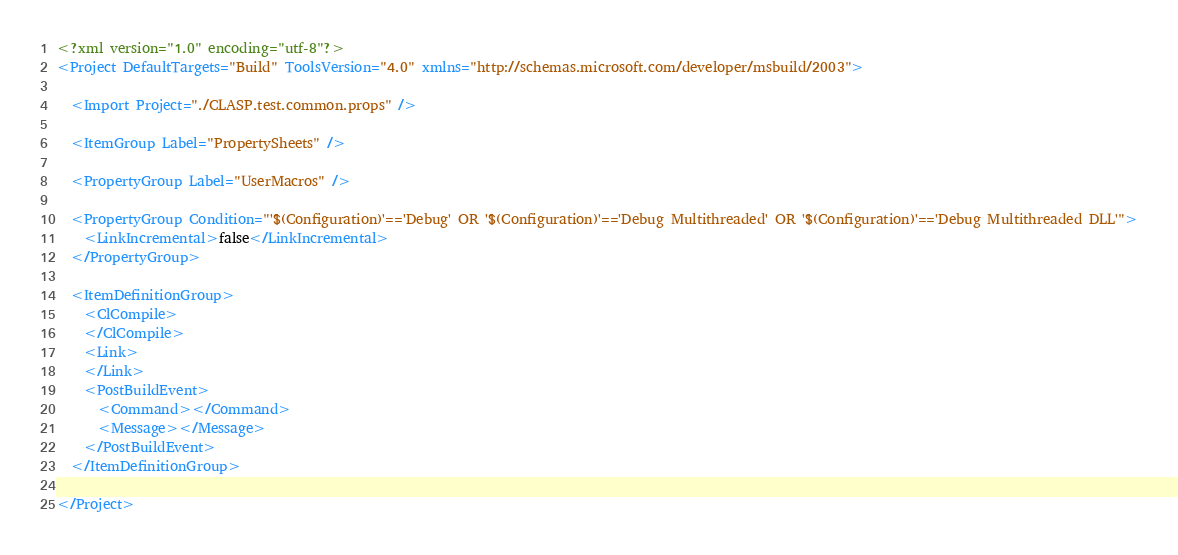Convert code to text. <code><loc_0><loc_0><loc_500><loc_500><_XML_><?xml version="1.0" encoding="utf-8"?>
<Project DefaultTargets="Build" ToolsVersion="4.0" xmlns="http://schemas.microsoft.com/developer/msbuild/2003">

  <Import Project="./CLASP.test.common.props" />

  <ItemGroup Label="PropertySheets" />

  <PropertyGroup Label="UserMacros" />

  <PropertyGroup Condition="'$(Configuration)'=='Debug' OR '$(Configuration)'=='Debug Multithreaded' OR '$(Configuration)'=='Debug Multithreaded DLL'">
    <LinkIncremental>false</LinkIncremental>
  </PropertyGroup>

  <ItemDefinitionGroup>
    <ClCompile>
    </ClCompile>
    <Link>
    </Link>
    <PostBuildEvent>
      <Command></Command>
      <Message></Message>
    </PostBuildEvent>
  </ItemDefinitionGroup>

</Project></code> 